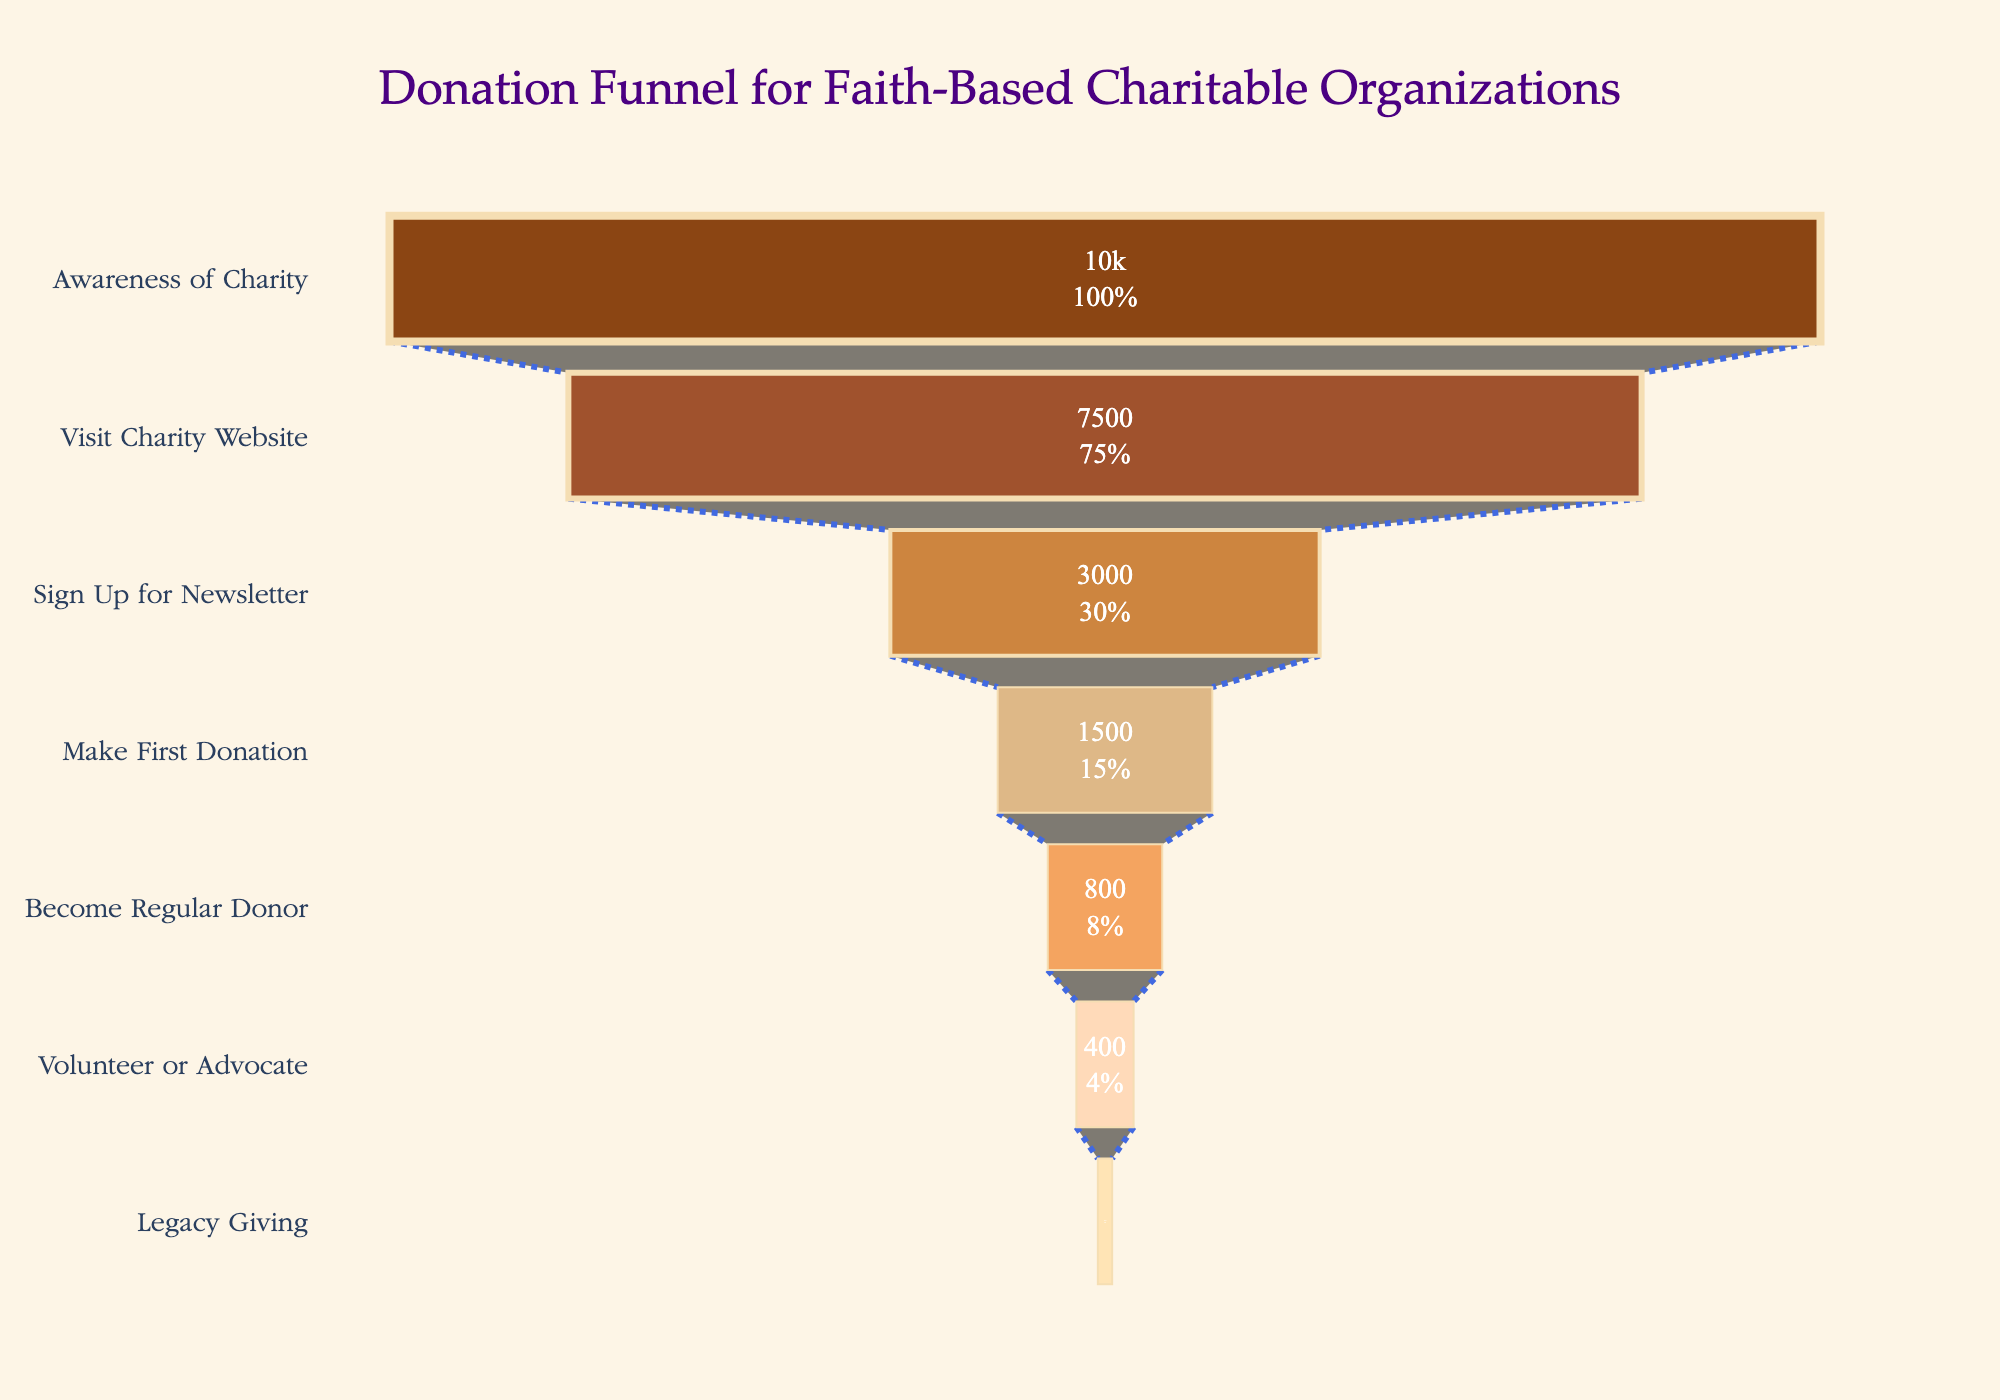What is the title of the funnel chart? The title is located at the top of the funnel chart and uses a larger font size, making it easy to identify.
Answer: Donation Funnel for Faith-Based Charitable Organizations How many stages are represented in the funnel chart? You can count the number of distinct stages listed on the y-axis, each representing a step in the funnel.
Answer: 7 What percentage of people who visit the charity website sign up for the newsletter? From the figure, you see that 3,000 people signed up for the newsletter out of 7,500 who visited the website. The percentage is calculated as (3000 / 7500) * 100.
Answer: 40% Which stage has the highest drop-off rate from the previous stage in terms of the number of people? To find the highest drop-off rate, calculate the difference between each stage and the preceding stage, then identify the largest drop. The stages are: Awareness to Visit (10000-7500=2500), Visit to Sign Up (7500-3000=4500), Sign Up to First Donation (3000-1500=1500), etc. The highest drop is between 'Visit Charity Website' and 'Sign Up for Newsletter'.
Answer: Visit Charity Website to Sign Up for Newsletter How many more people are aware of the charity compared to those who make their first donation? Subtract the number of people who made the first donation from those who are aware of the charity: 10000 - 1500.
Answer: 8500 What is the final stage of the donation funnel? The funnel stages are listed sequentially on the y-axis. Reading from top to bottom, the final stage is at the bottom.
Answer: Legacy Giving What proportion of people become regular donors out of those who make their first donation? Calculate the proportion by dividing the number who become regular donors by those who make their first donation: (800 / 1500) * 100.
Answer: Approximately 53.3% Between which two consecutive stages is the smallest decrease in the number of people observed? Calculate the decrease between each pair of consecutive stages, then find the smallest value. The stages are: Awareness to Visit 2500, Visit to Sign Up 4500, Sign Up to First Donation 1500, First Donation to Regular Donor 700, Regular Donor to Volunteer 400, Volunteer to Legacy Giving 300. The smallest decrease is between Regular Donor and Volunteer.
Answer: Become Regular Donor to Volunteer or Advocate What is the second smallest percentage drop between two consecutive stages? First, calculate the percentage drop between each pair of consecutive stages: Awareness to Visit (2500/10000)*100=25%, Visit to Sign Up (4500/7500)*100=60%, Sign Up to First Donation (1500/3000)*100=50%, First Donation to Regular Donor (700/1500)*100=46.67%, Regular Donor to Volunteer (400/800)*100=50%, Volunteer to Legacy Giving (300/400)*100=75%. The second smallest drop is between First Donation to Become Regular Donor (46.67%).
Answer: Make First Donation to Become Regular Donor Which stage has the least number of people, and how many are in that stage? Look at the x-axis values to identify the smallest number, then find the corresponding stage on the y-axis.
Answer: Legacy Giving, 100 